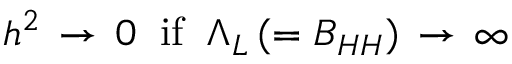<formula> <loc_0><loc_0><loc_500><loc_500>h ^ { 2 } \, \rightarrow \, 0 \, i f \, \Lambda _ { L } \, ( = B _ { H H } ) \, \rightarrow \, \infty</formula> 